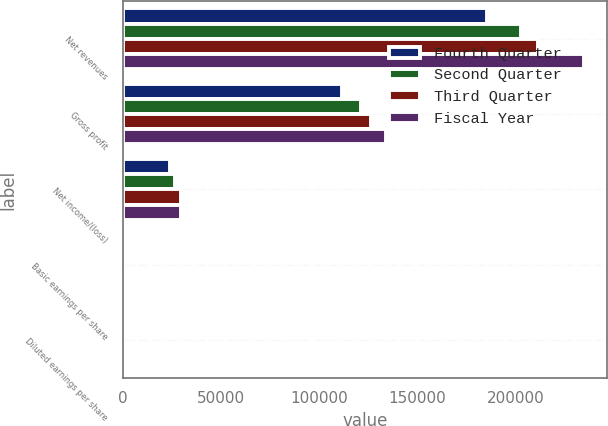Convert chart to OTSL. <chart><loc_0><loc_0><loc_500><loc_500><stacked_bar_chart><ecel><fcel>Net revenues<fcel>Gross profit<fcel>Net income/(loss)<fcel>Basic earnings per share<fcel>Diluted earnings per share<nl><fcel>Fourth Quarter<fcel>185740<fcel>111777<fcel>24125<fcel>0.31<fcel>0.3<nl><fcel>Second Quarter<fcel>202679<fcel>121331<fcel>26861<fcel>0.35<fcel>0.34<nl><fcel>Third Quarter<fcel>211827<fcel>126558<fcel>29684<fcel>0.38<fcel>0.38<nl><fcel>Fiscal Year<fcel>235151<fcel>134084<fcel>29633<fcel>0.38<fcel>0.38<nl></chart> 